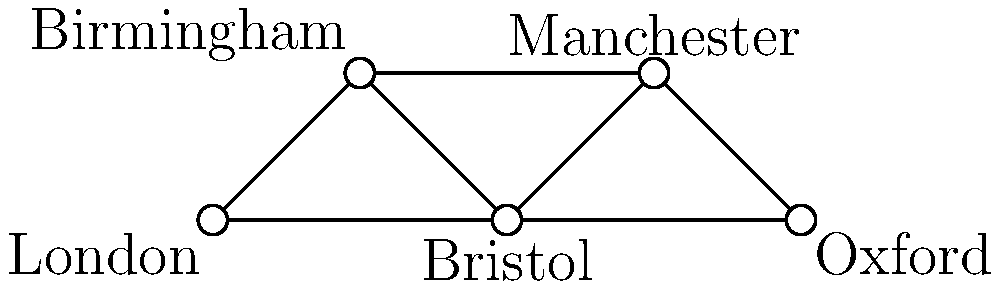In the 1960s, a British classic car spare parts distributor operated a network connecting five major cities: London, Birmingham, Bristol, Manchester, and Oxford. The network is represented by the graph above, where each edge indicates a direct distribution route between two cities. What is the minimum number of distribution routes that need to be closed to completely isolate London from Oxford, preventing any spare parts from reaching Oxford from London? To solve this problem, we need to use the concept of edge connectivity in graph theory. The question is essentially asking for the minimum cut between London and Oxford.

Step 1: Identify all possible paths from London to Oxford.
Path 1: London -> Birmingham -> Manchester -> Oxford
Path 2: London -> Bristol -> Oxford
Path 3: London -> Bristol -> Birmingham -> Manchester -> Oxford

Step 2: Analyze the paths to find the minimum number of edges that, when removed, will disconnect all paths.

Step 3: We can see that all paths go through Bristol. If we remove the edges London-Bristol and Bristol-Oxford, it will disconnect all paths between London and Oxford.

Step 4: Count the number of edges that need to be removed. In this case, it's 2 edges: London-Bristol and Bristol-Oxford.

Therefore, the minimum number of distribution routes that need to be closed to completely isolate London from Oxford is 2.
Answer: 2 